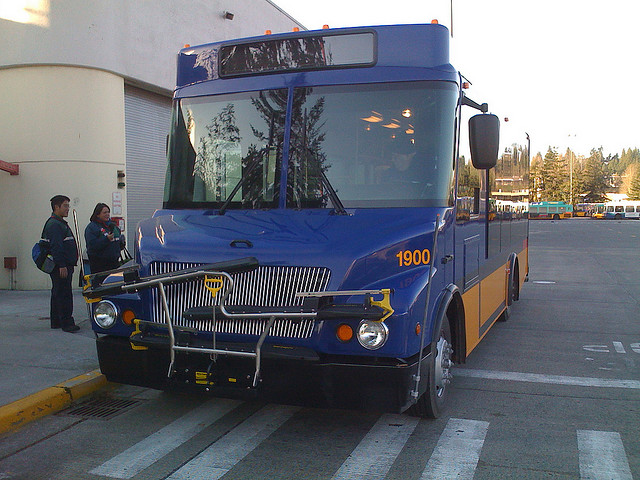Please extract the text content from this image. 1900 